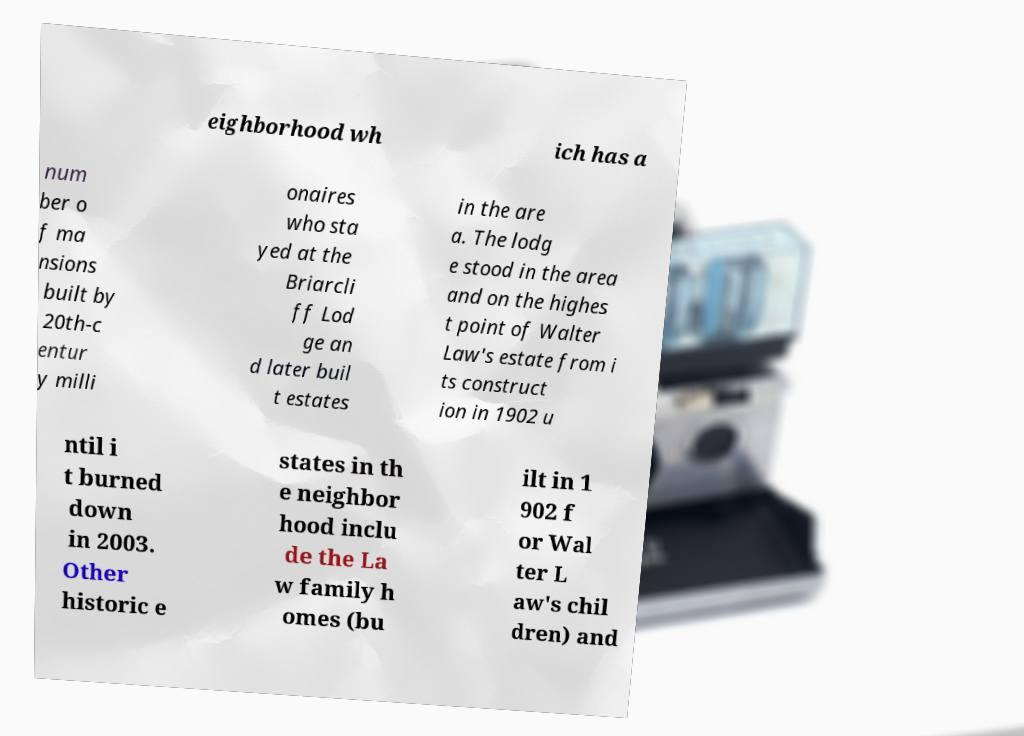I need the written content from this picture converted into text. Can you do that? eighborhood wh ich has a num ber o f ma nsions built by 20th-c entur y milli onaires who sta yed at the Briarcli ff Lod ge an d later buil t estates in the are a. The lodg e stood in the area and on the highes t point of Walter Law's estate from i ts construct ion in 1902 u ntil i t burned down in 2003. Other historic e states in th e neighbor hood inclu de the La w family h omes (bu ilt in 1 902 f or Wal ter L aw's chil dren) and 